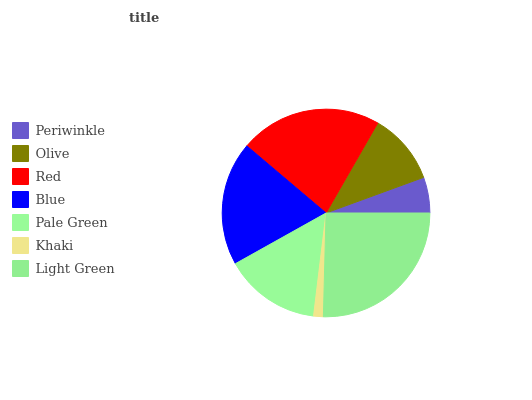Is Khaki the minimum?
Answer yes or no. Yes. Is Light Green the maximum?
Answer yes or no. Yes. Is Olive the minimum?
Answer yes or no. No. Is Olive the maximum?
Answer yes or no. No. Is Olive greater than Periwinkle?
Answer yes or no. Yes. Is Periwinkle less than Olive?
Answer yes or no. Yes. Is Periwinkle greater than Olive?
Answer yes or no. No. Is Olive less than Periwinkle?
Answer yes or no. No. Is Pale Green the high median?
Answer yes or no. Yes. Is Pale Green the low median?
Answer yes or no. Yes. Is Blue the high median?
Answer yes or no. No. Is Light Green the low median?
Answer yes or no. No. 